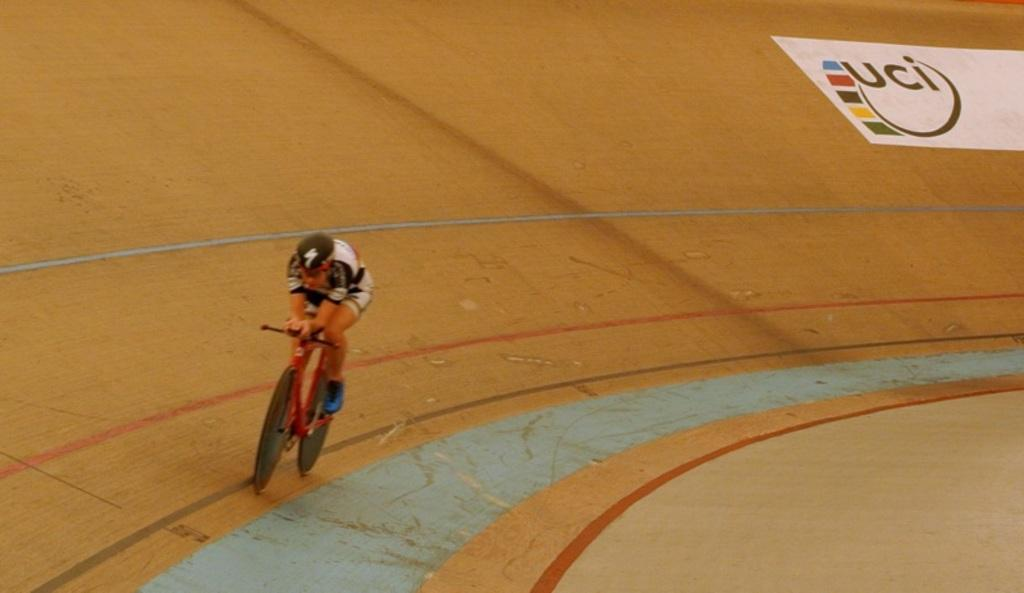What is the main subject of the image? There is a person in the image. What is the person doing in the image? The person is cycling. Can you describe the setting where the person is cycling? The cycling track is in the center of the image. What type of wool can be seen on the person's finger in the image? There is no wool or finger present in the image; the person is cycling on a track. 